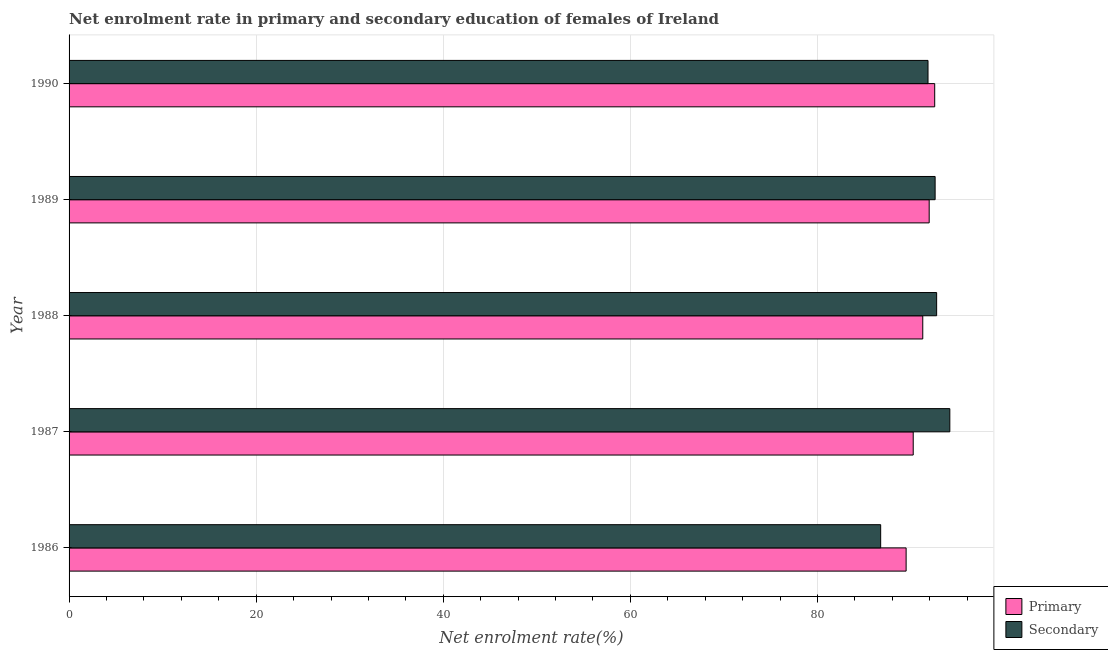How many groups of bars are there?
Your response must be concise. 5. Are the number of bars per tick equal to the number of legend labels?
Your answer should be compact. Yes. Are the number of bars on each tick of the Y-axis equal?
Your response must be concise. Yes. How many bars are there on the 3rd tick from the top?
Make the answer very short. 2. How many bars are there on the 5th tick from the bottom?
Offer a very short reply. 2. What is the enrollment rate in primary education in 1989?
Your answer should be very brief. 91.94. Across all years, what is the maximum enrollment rate in secondary education?
Make the answer very short. 94.14. Across all years, what is the minimum enrollment rate in secondary education?
Your response must be concise. 86.75. In which year was the enrollment rate in primary education maximum?
Ensure brevity in your answer.  1990. In which year was the enrollment rate in primary education minimum?
Give a very brief answer. 1986. What is the total enrollment rate in primary education in the graph?
Your answer should be compact. 455.42. What is the difference between the enrollment rate in secondary education in 1986 and that in 1990?
Keep it short and to the point. -5.06. What is the difference between the enrollment rate in primary education in 1987 and the enrollment rate in secondary education in 1986?
Offer a very short reply. 3.48. What is the average enrollment rate in primary education per year?
Your answer should be very brief. 91.08. In the year 1988, what is the difference between the enrollment rate in primary education and enrollment rate in secondary education?
Offer a very short reply. -1.48. Is the enrollment rate in secondary education in 1989 less than that in 1990?
Offer a terse response. No. What is the difference between the highest and the second highest enrollment rate in primary education?
Give a very brief answer. 0.59. What is the difference between the highest and the lowest enrollment rate in secondary education?
Provide a succinct answer. 7.39. Is the sum of the enrollment rate in primary education in 1988 and 1990 greater than the maximum enrollment rate in secondary education across all years?
Offer a very short reply. Yes. What does the 2nd bar from the top in 1990 represents?
Your answer should be very brief. Primary. What does the 2nd bar from the bottom in 1986 represents?
Offer a terse response. Secondary. How many years are there in the graph?
Keep it short and to the point. 5. Does the graph contain grids?
Keep it short and to the point. Yes. Where does the legend appear in the graph?
Offer a terse response. Bottom right. How many legend labels are there?
Provide a succinct answer. 2. How are the legend labels stacked?
Offer a very short reply. Vertical. What is the title of the graph?
Offer a terse response. Net enrolment rate in primary and secondary education of females of Ireland. What is the label or title of the X-axis?
Your answer should be compact. Net enrolment rate(%). What is the label or title of the Y-axis?
Provide a short and direct response. Year. What is the Net enrolment rate(%) of Primary in 1986?
Make the answer very short. 89.47. What is the Net enrolment rate(%) of Secondary in 1986?
Ensure brevity in your answer.  86.75. What is the Net enrolment rate(%) of Primary in 1987?
Offer a terse response. 90.23. What is the Net enrolment rate(%) of Secondary in 1987?
Ensure brevity in your answer.  94.14. What is the Net enrolment rate(%) of Primary in 1988?
Offer a very short reply. 91.25. What is the Net enrolment rate(%) in Secondary in 1988?
Your response must be concise. 92.73. What is the Net enrolment rate(%) of Primary in 1989?
Keep it short and to the point. 91.94. What is the Net enrolment rate(%) of Secondary in 1989?
Your answer should be compact. 92.57. What is the Net enrolment rate(%) in Primary in 1990?
Your response must be concise. 92.53. What is the Net enrolment rate(%) of Secondary in 1990?
Your answer should be compact. 91.81. Across all years, what is the maximum Net enrolment rate(%) in Primary?
Your response must be concise. 92.53. Across all years, what is the maximum Net enrolment rate(%) in Secondary?
Keep it short and to the point. 94.14. Across all years, what is the minimum Net enrolment rate(%) of Primary?
Keep it short and to the point. 89.47. Across all years, what is the minimum Net enrolment rate(%) of Secondary?
Offer a terse response. 86.75. What is the total Net enrolment rate(%) of Primary in the graph?
Ensure brevity in your answer.  455.42. What is the total Net enrolment rate(%) of Secondary in the graph?
Give a very brief answer. 458.02. What is the difference between the Net enrolment rate(%) of Primary in 1986 and that in 1987?
Offer a very short reply. -0.76. What is the difference between the Net enrolment rate(%) of Secondary in 1986 and that in 1987?
Your answer should be very brief. -7.39. What is the difference between the Net enrolment rate(%) of Primary in 1986 and that in 1988?
Provide a short and direct response. -1.78. What is the difference between the Net enrolment rate(%) in Secondary in 1986 and that in 1988?
Your answer should be compact. -5.98. What is the difference between the Net enrolment rate(%) in Primary in 1986 and that in 1989?
Provide a succinct answer. -2.47. What is the difference between the Net enrolment rate(%) in Secondary in 1986 and that in 1989?
Provide a succinct answer. -5.82. What is the difference between the Net enrolment rate(%) of Primary in 1986 and that in 1990?
Offer a very short reply. -3.06. What is the difference between the Net enrolment rate(%) in Secondary in 1986 and that in 1990?
Offer a very short reply. -5.06. What is the difference between the Net enrolment rate(%) in Primary in 1987 and that in 1988?
Offer a terse response. -1.02. What is the difference between the Net enrolment rate(%) of Secondary in 1987 and that in 1988?
Offer a very short reply. 1.41. What is the difference between the Net enrolment rate(%) in Primary in 1987 and that in 1989?
Your answer should be compact. -1.71. What is the difference between the Net enrolment rate(%) of Secondary in 1987 and that in 1989?
Keep it short and to the point. 1.57. What is the difference between the Net enrolment rate(%) of Primary in 1987 and that in 1990?
Provide a short and direct response. -2.3. What is the difference between the Net enrolment rate(%) in Secondary in 1987 and that in 1990?
Offer a terse response. 2.33. What is the difference between the Net enrolment rate(%) in Primary in 1988 and that in 1989?
Offer a terse response. -0.69. What is the difference between the Net enrolment rate(%) of Secondary in 1988 and that in 1989?
Offer a terse response. 0.16. What is the difference between the Net enrolment rate(%) of Primary in 1988 and that in 1990?
Ensure brevity in your answer.  -1.28. What is the difference between the Net enrolment rate(%) of Secondary in 1988 and that in 1990?
Your response must be concise. 0.92. What is the difference between the Net enrolment rate(%) in Primary in 1989 and that in 1990?
Make the answer very short. -0.59. What is the difference between the Net enrolment rate(%) in Secondary in 1989 and that in 1990?
Give a very brief answer. 0.76. What is the difference between the Net enrolment rate(%) of Primary in 1986 and the Net enrolment rate(%) of Secondary in 1987?
Your answer should be very brief. -4.67. What is the difference between the Net enrolment rate(%) of Primary in 1986 and the Net enrolment rate(%) of Secondary in 1988?
Your answer should be compact. -3.26. What is the difference between the Net enrolment rate(%) of Primary in 1986 and the Net enrolment rate(%) of Secondary in 1989?
Give a very brief answer. -3.1. What is the difference between the Net enrolment rate(%) in Primary in 1986 and the Net enrolment rate(%) in Secondary in 1990?
Keep it short and to the point. -2.34. What is the difference between the Net enrolment rate(%) of Primary in 1987 and the Net enrolment rate(%) of Secondary in 1988?
Make the answer very short. -2.5. What is the difference between the Net enrolment rate(%) of Primary in 1987 and the Net enrolment rate(%) of Secondary in 1989?
Your answer should be compact. -2.34. What is the difference between the Net enrolment rate(%) of Primary in 1987 and the Net enrolment rate(%) of Secondary in 1990?
Ensure brevity in your answer.  -1.58. What is the difference between the Net enrolment rate(%) of Primary in 1988 and the Net enrolment rate(%) of Secondary in 1989?
Your answer should be compact. -1.32. What is the difference between the Net enrolment rate(%) of Primary in 1988 and the Net enrolment rate(%) of Secondary in 1990?
Ensure brevity in your answer.  -0.56. What is the difference between the Net enrolment rate(%) of Primary in 1989 and the Net enrolment rate(%) of Secondary in 1990?
Give a very brief answer. 0.13. What is the average Net enrolment rate(%) in Primary per year?
Your answer should be very brief. 91.08. What is the average Net enrolment rate(%) in Secondary per year?
Make the answer very short. 91.6. In the year 1986, what is the difference between the Net enrolment rate(%) in Primary and Net enrolment rate(%) in Secondary?
Your answer should be compact. 2.72. In the year 1987, what is the difference between the Net enrolment rate(%) of Primary and Net enrolment rate(%) of Secondary?
Keep it short and to the point. -3.91. In the year 1988, what is the difference between the Net enrolment rate(%) of Primary and Net enrolment rate(%) of Secondary?
Make the answer very short. -1.48. In the year 1989, what is the difference between the Net enrolment rate(%) in Primary and Net enrolment rate(%) in Secondary?
Keep it short and to the point. -0.64. In the year 1990, what is the difference between the Net enrolment rate(%) of Primary and Net enrolment rate(%) of Secondary?
Keep it short and to the point. 0.71. What is the ratio of the Net enrolment rate(%) of Primary in 1986 to that in 1987?
Provide a short and direct response. 0.99. What is the ratio of the Net enrolment rate(%) of Secondary in 1986 to that in 1987?
Ensure brevity in your answer.  0.92. What is the ratio of the Net enrolment rate(%) in Primary in 1986 to that in 1988?
Your answer should be very brief. 0.98. What is the ratio of the Net enrolment rate(%) of Secondary in 1986 to that in 1988?
Your answer should be very brief. 0.94. What is the ratio of the Net enrolment rate(%) in Primary in 1986 to that in 1989?
Provide a succinct answer. 0.97. What is the ratio of the Net enrolment rate(%) in Secondary in 1986 to that in 1989?
Ensure brevity in your answer.  0.94. What is the ratio of the Net enrolment rate(%) of Secondary in 1986 to that in 1990?
Your response must be concise. 0.94. What is the ratio of the Net enrolment rate(%) of Primary in 1987 to that in 1988?
Your response must be concise. 0.99. What is the ratio of the Net enrolment rate(%) in Secondary in 1987 to that in 1988?
Keep it short and to the point. 1.02. What is the ratio of the Net enrolment rate(%) of Primary in 1987 to that in 1989?
Provide a short and direct response. 0.98. What is the ratio of the Net enrolment rate(%) of Secondary in 1987 to that in 1989?
Keep it short and to the point. 1.02. What is the ratio of the Net enrolment rate(%) in Primary in 1987 to that in 1990?
Offer a terse response. 0.98. What is the ratio of the Net enrolment rate(%) in Secondary in 1987 to that in 1990?
Make the answer very short. 1.03. What is the ratio of the Net enrolment rate(%) of Primary in 1988 to that in 1989?
Provide a succinct answer. 0.99. What is the ratio of the Net enrolment rate(%) in Primary in 1988 to that in 1990?
Offer a terse response. 0.99. What is the ratio of the Net enrolment rate(%) in Secondary in 1988 to that in 1990?
Give a very brief answer. 1.01. What is the ratio of the Net enrolment rate(%) in Primary in 1989 to that in 1990?
Your answer should be very brief. 0.99. What is the ratio of the Net enrolment rate(%) in Secondary in 1989 to that in 1990?
Make the answer very short. 1.01. What is the difference between the highest and the second highest Net enrolment rate(%) in Primary?
Provide a succinct answer. 0.59. What is the difference between the highest and the second highest Net enrolment rate(%) in Secondary?
Your response must be concise. 1.41. What is the difference between the highest and the lowest Net enrolment rate(%) in Primary?
Ensure brevity in your answer.  3.06. What is the difference between the highest and the lowest Net enrolment rate(%) in Secondary?
Provide a succinct answer. 7.39. 